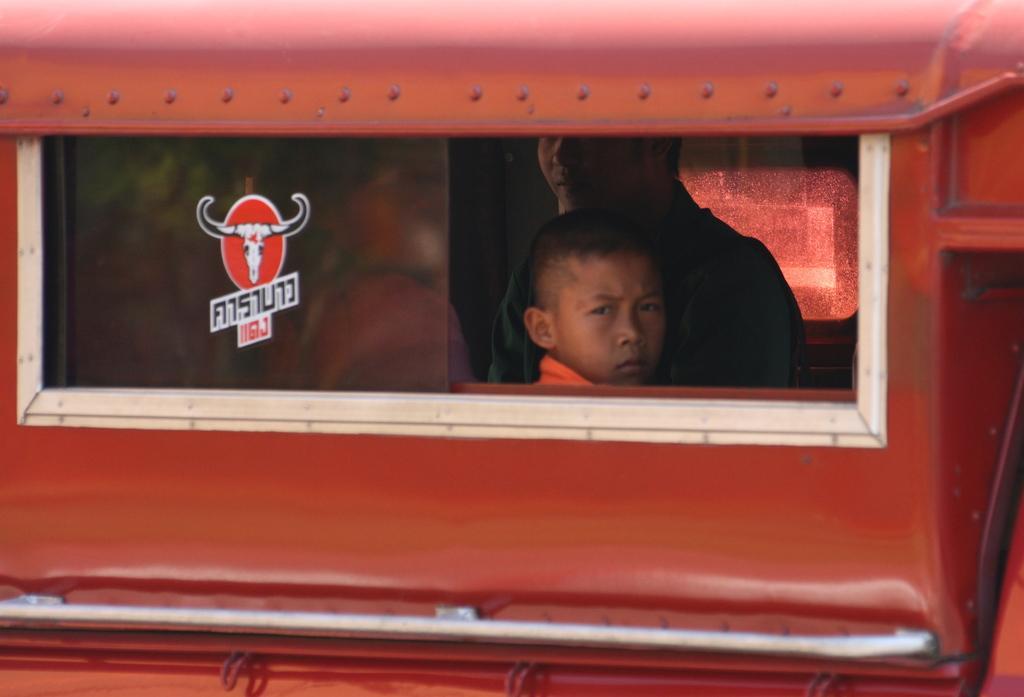Could you give a brief overview of what you see in this image? In this image we can see few persons are sitting inside a vehicle and there is a sticker on the window glass of the vehicle. 